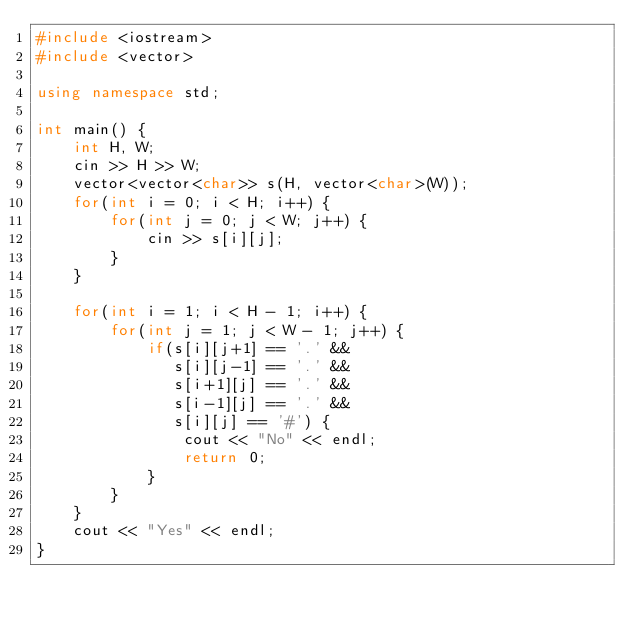Convert code to text. <code><loc_0><loc_0><loc_500><loc_500><_C++_>#include <iostream>
#include <vector>

using namespace std;

int main() {
	int H, W;
	cin >> H >> W;
	vector<vector<char>> s(H, vector<char>(W));
	for(int i = 0; i < H; i++) {
		for(int j = 0; j < W; j++) {
			cin >> s[i][j];
		}
	}

	for(int i = 1; i < H - 1; i++) {
		for(int j = 1; j < W - 1; j++) {
			if(s[i][j+1] == '.' &&
			   s[i][j-1] == '.' &&
			   s[i+1][j] == '.' &&
			   s[i-1][j] == '.' &&
			   s[i][j] == '#') {
				cout << "No" << endl;
				return 0;
			}
		}
	}
	cout << "Yes" << endl;
}
</code> 